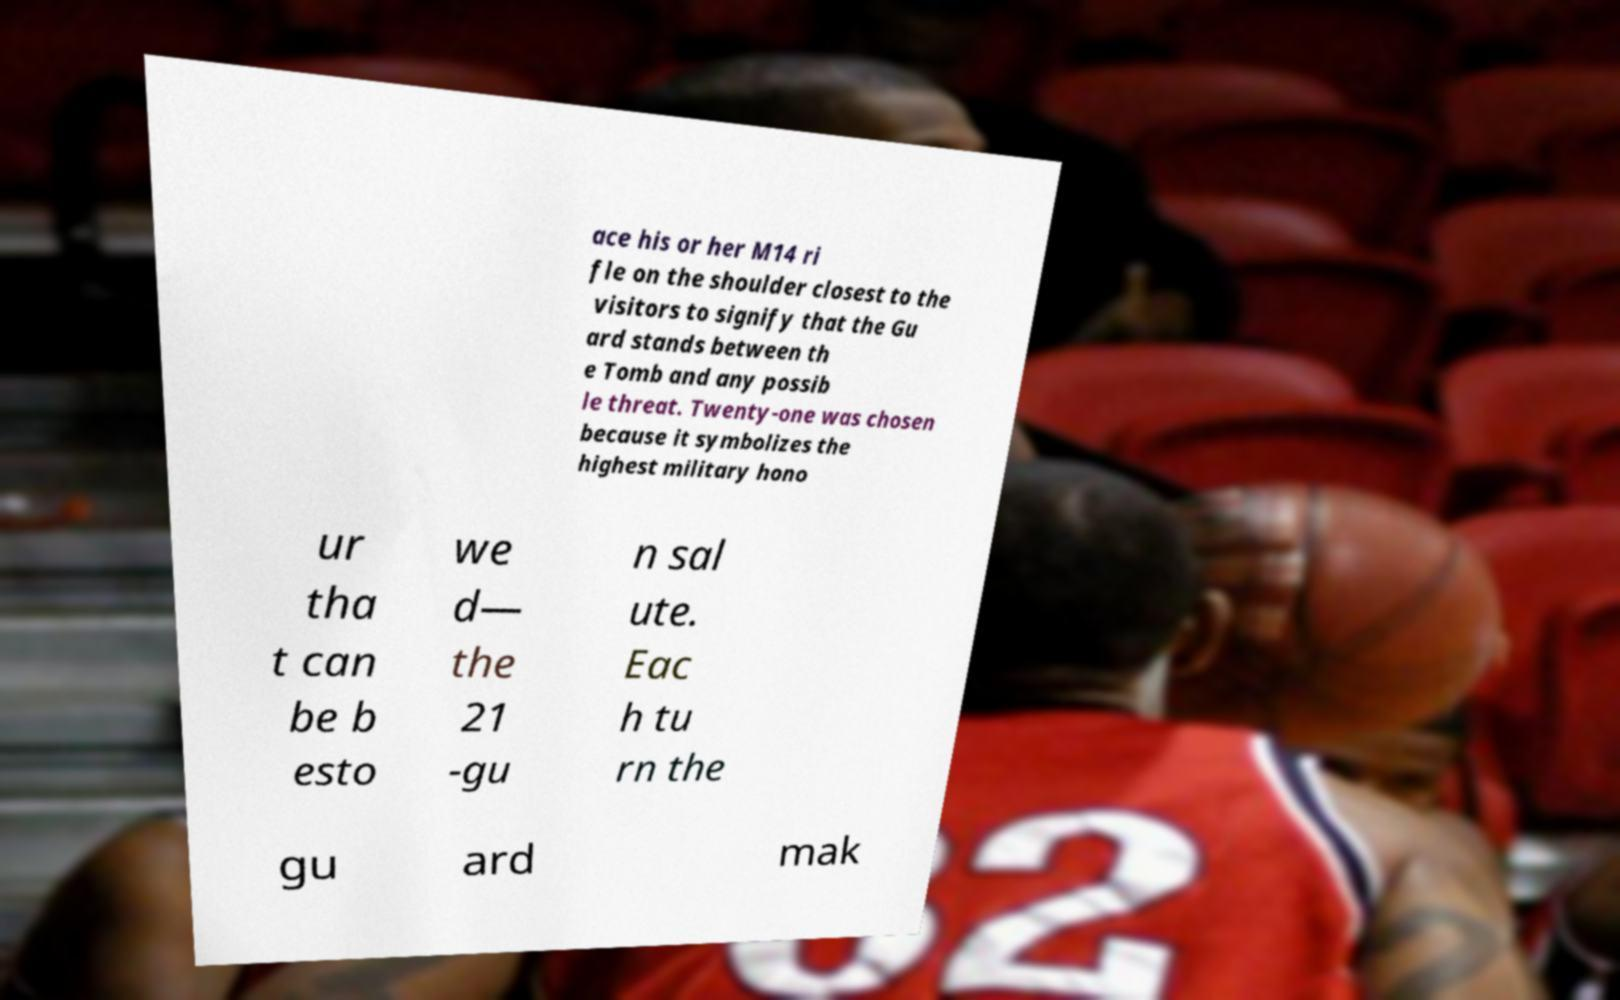Could you extract and type out the text from this image? ace his or her M14 ri fle on the shoulder closest to the visitors to signify that the Gu ard stands between th e Tomb and any possib le threat. Twenty-one was chosen because it symbolizes the highest military hono ur tha t can be b esto we d— the 21 -gu n sal ute. Eac h tu rn the gu ard mak 